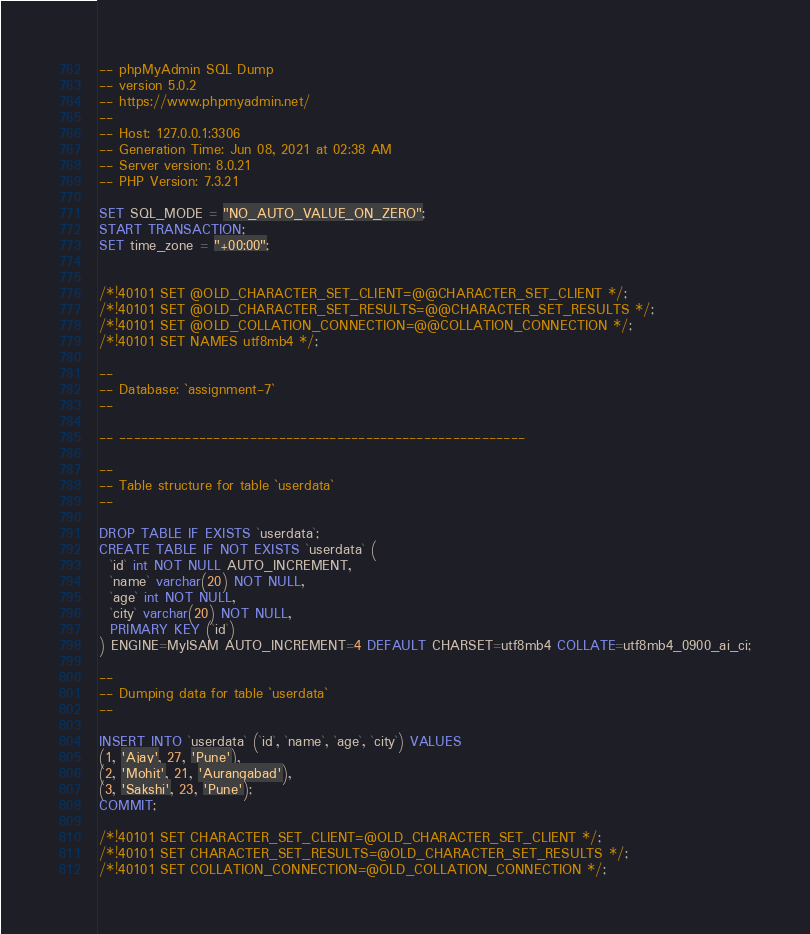Convert code to text. <code><loc_0><loc_0><loc_500><loc_500><_SQL_>-- phpMyAdmin SQL Dump
-- version 5.0.2
-- https://www.phpmyadmin.net/
--
-- Host: 127.0.0.1:3306
-- Generation Time: Jun 08, 2021 at 02:38 AM
-- Server version: 8.0.21
-- PHP Version: 7.3.21

SET SQL_MODE = "NO_AUTO_VALUE_ON_ZERO";
START TRANSACTION;
SET time_zone = "+00:00";


/*!40101 SET @OLD_CHARACTER_SET_CLIENT=@@CHARACTER_SET_CLIENT */;
/*!40101 SET @OLD_CHARACTER_SET_RESULTS=@@CHARACTER_SET_RESULTS */;
/*!40101 SET @OLD_COLLATION_CONNECTION=@@COLLATION_CONNECTION */;
/*!40101 SET NAMES utf8mb4 */;

--
-- Database: `assignment-7`
--

-- --------------------------------------------------------

--
-- Table structure for table `userdata`
--

DROP TABLE IF EXISTS `userdata`;
CREATE TABLE IF NOT EXISTS `userdata` (
  `id` int NOT NULL AUTO_INCREMENT,
  `name` varchar(20) NOT NULL,
  `age` int NOT NULL,
  `city` varchar(20) NOT NULL,
  PRIMARY KEY (`id`)
) ENGINE=MyISAM AUTO_INCREMENT=4 DEFAULT CHARSET=utf8mb4 COLLATE=utf8mb4_0900_ai_ci;

--
-- Dumping data for table `userdata`
--

INSERT INTO `userdata` (`id`, `name`, `age`, `city`) VALUES
(1, 'Ajay', 27, 'Pune'),
(2, 'Mohit', 21, 'Aurangabad'),
(3, 'Sakshi', 23, 'Pune');
COMMIT;

/*!40101 SET CHARACTER_SET_CLIENT=@OLD_CHARACTER_SET_CLIENT */;
/*!40101 SET CHARACTER_SET_RESULTS=@OLD_CHARACTER_SET_RESULTS */;
/*!40101 SET COLLATION_CONNECTION=@OLD_COLLATION_CONNECTION */;
</code> 